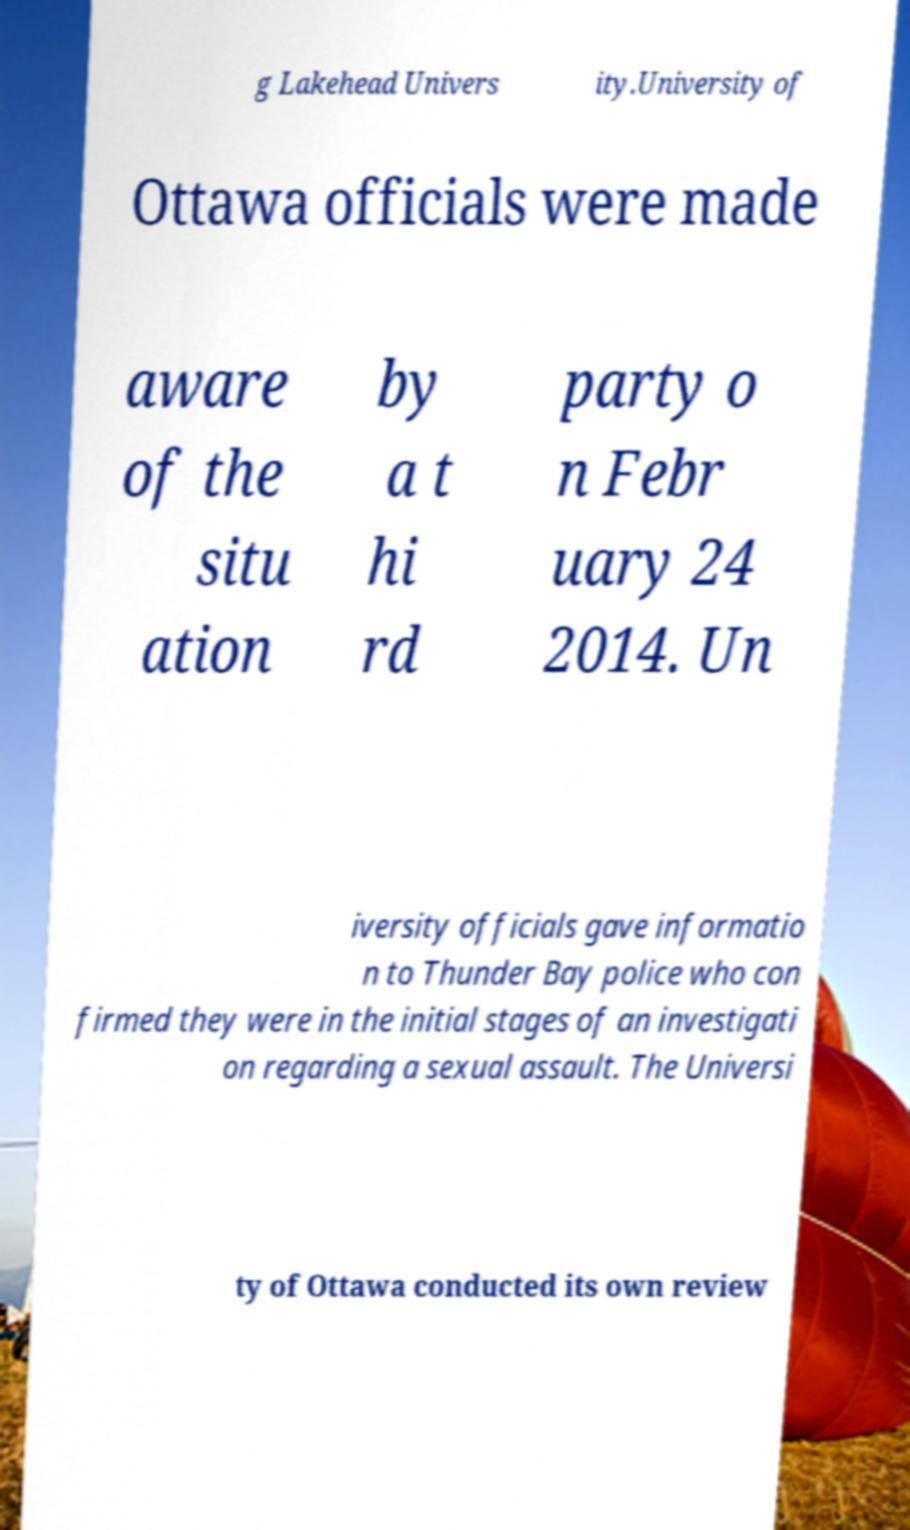What messages or text are displayed in this image? I need them in a readable, typed format. g Lakehead Univers ity.University of Ottawa officials were made aware of the situ ation by a t hi rd party o n Febr uary 24 2014. Un iversity officials gave informatio n to Thunder Bay police who con firmed they were in the initial stages of an investigati on regarding a sexual assault. The Universi ty of Ottawa conducted its own review 